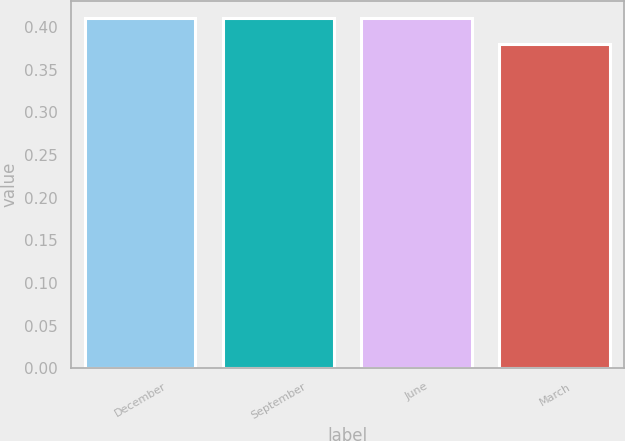Convert chart to OTSL. <chart><loc_0><loc_0><loc_500><loc_500><bar_chart><fcel>December<fcel>September<fcel>June<fcel>March<nl><fcel>0.41<fcel>0.41<fcel>0.41<fcel>0.38<nl></chart> 